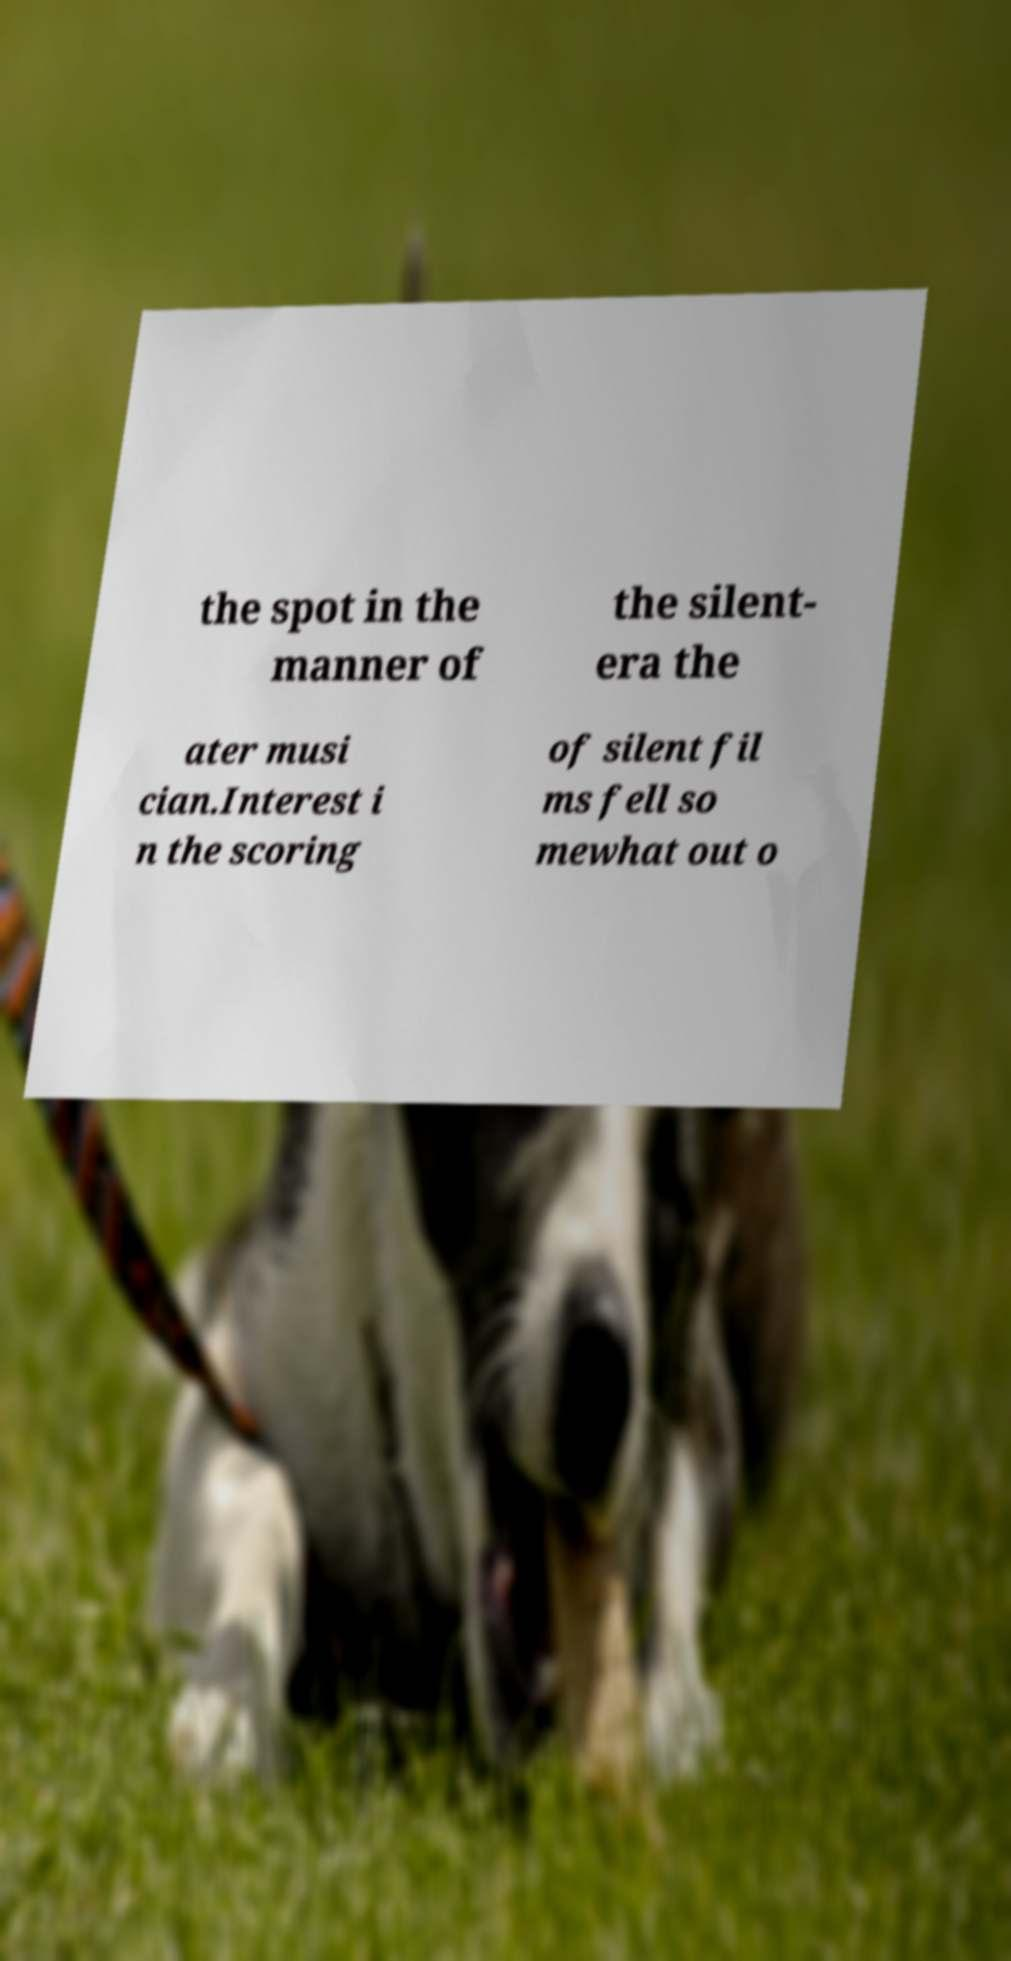What messages or text are displayed in this image? I need them in a readable, typed format. the spot in the manner of the silent- era the ater musi cian.Interest i n the scoring of silent fil ms fell so mewhat out o 